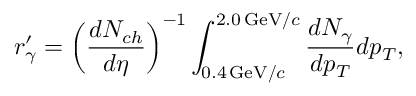Convert formula to latex. <formula><loc_0><loc_0><loc_500><loc_500>r _ { \gamma } ^ { \prime } = \left ( \frac { d N _ { c h } } { d \eta } \right ) ^ { - 1 } \int _ { 0 . 4 \, G e V / c } ^ { 2 . 0 \, G e V / c } \frac { d N _ { \gamma } } { d p _ { T } } d p _ { T } ,</formula> 